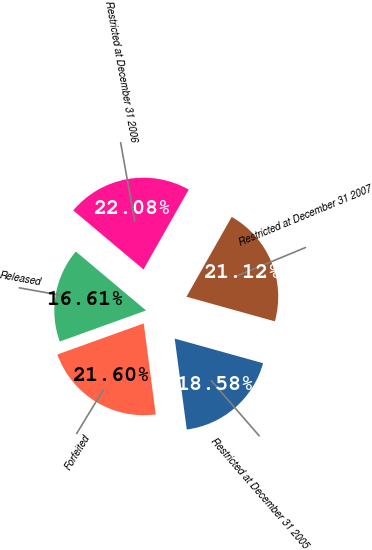Convert chart to OTSL. <chart><loc_0><loc_0><loc_500><loc_500><pie_chart><fcel>Restricted at December 31 2005<fcel>Forfeited<fcel>Released<fcel>Restricted at December 31 2006<fcel>Restricted at December 31 2007<nl><fcel>18.58%<fcel>21.6%<fcel>16.61%<fcel>22.08%<fcel>21.12%<nl></chart> 